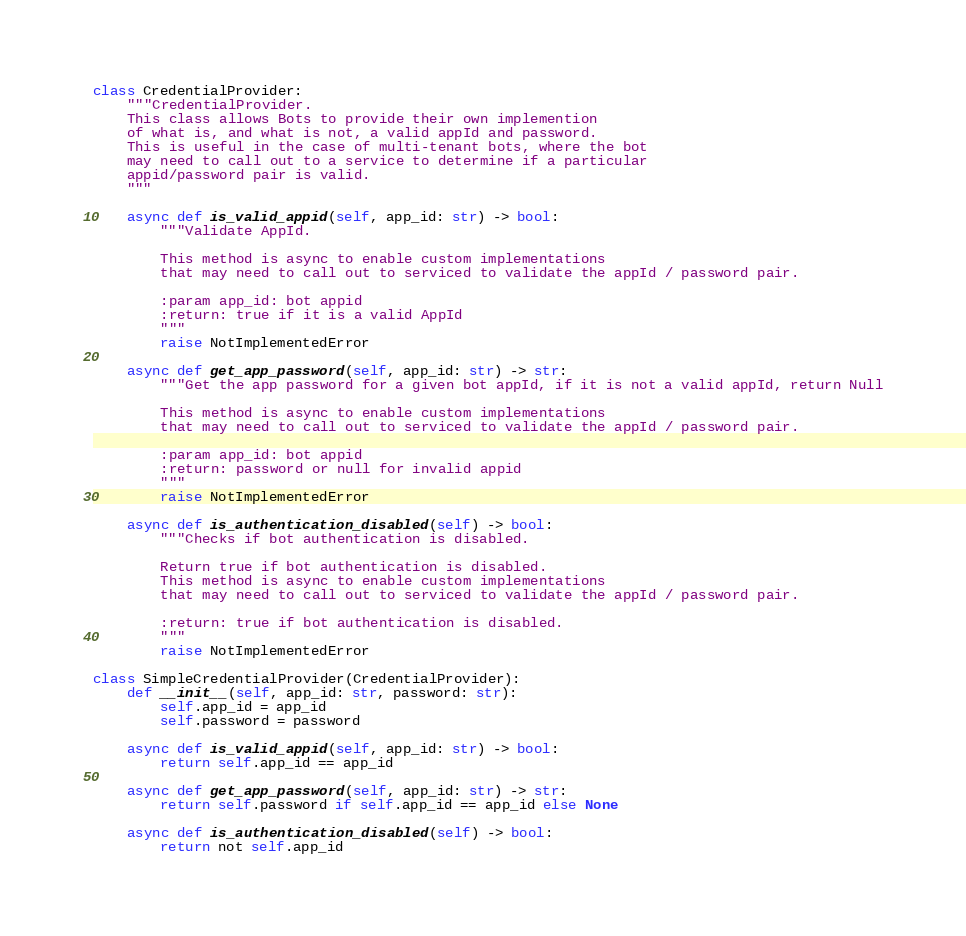<code> <loc_0><loc_0><loc_500><loc_500><_Python_>class CredentialProvider:
    """CredentialProvider.
    This class allows Bots to provide their own implemention
    of what is, and what is not, a valid appId and password.
    This is useful in the case of multi-tenant bots, where the bot
    may need to call out to a service to determine if a particular
    appid/password pair is valid.
    """

    async def is_valid_appid(self, app_id: str) -> bool:
        """Validate AppId.

        This method is async to enable custom implementations
        that may need to call out to serviced to validate the appId / password pair.

        :param app_id: bot appid
        :return: true if it is a valid AppId
        """
        raise NotImplementedError

    async def get_app_password(self, app_id: str) -> str:
        """Get the app password for a given bot appId, if it is not a valid appId, return Null

        This method is async to enable custom implementations
        that may need to call out to serviced to validate the appId / password pair.

        :param app_id: bot appid
        :return: password or null for invalid appid
        """
        raise NotImplementedError

    async def is_authentication_disabled(self) -> bool:
        """Checks if bot authentication is disabled.

        Return true if bot authentication is disabled.
        This method is async to enable custom implementations
        that may need to call out to serviced to validate the appId / password pair.

        :return: true if bot authentication is disabled.
        """
        raise NotImplementedError

class SimpleCredentialProvider(CredentialProvider):
    def __init__(self, app_id: str, password: str):
        self.app_id = app_id
        self.password = password

    async def is_valid_appid(self, app_id: str) -> bool:
        return self.app_id == app_id

    async def get_app_password(self, app_id: str) -> str:
        return self.password if self.app_id == app_id else None

    async def is_authentication_disabled(self) -> bool:
        return not self.app_id
</code> 